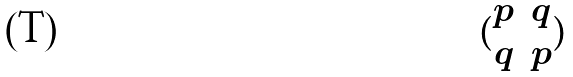Convert formula to latex. <formula><loc_0><loc_0><loc_500><loc_500>( \begin{matrix} p & q \\ q & p \end{matrix} )</formula> 